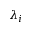Convert formula to latex. <formula><loc_0><loc_0><loc_500><loc_500>\lambda _ { i }</formula> 